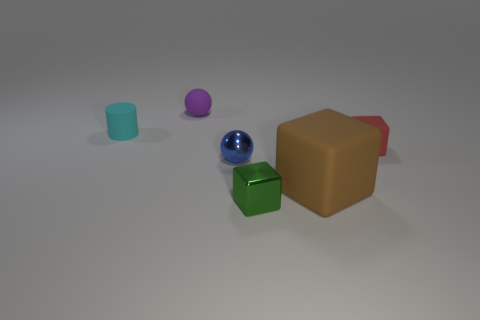Subtract all small green shiny cubes. How many cubes are left? 2 Add 2 yellow balls. How many objects exist? 8 Subtract 1 cylinders. How many cylinders are left? 0 Subtract all purple balls. How many balls are left? 1 Subtract all balls. How many objects are left? 4 Add 3 tiny red blocks. How many tiny red blocks are left? 4 Add 6 tiny purple objects. How many tiny purple objects exist? 7 Subtract 0 gray cylinders. How many objects are left? 6 Subtract all green cylinders. Subtract all green blocks. How many cylinders are left? 1 Subtract all small purple things. Subtract all tiny purple metallic balls. How many objects are left? 5 